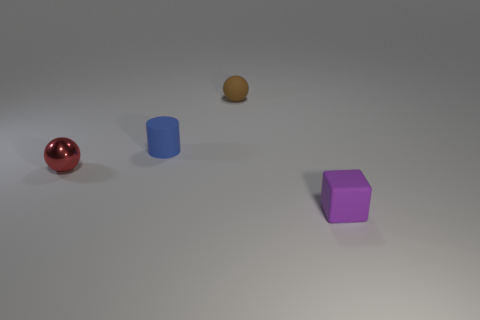Are there any tiny purple matte objects on the right side of the small purple rubber thing?
Your response must be concise. No. What number of objects are either objects that are in front of the small metal sphere or big gray blocks?
Your answer should be very brief. 1. There is a matte object that is behind the blue cylinder; what number of metal objects are left of it?
Offer a very short reply. 1. Are there fewer tiny metal spheres to the right of the tiny shiny thing than tiny brown rubber objects on the left side of the blue matte object?
Provide a short and direct response. No. What is the shape of the tiny matte thing that is to the right of the thing behind the blue thing?
Your answer should be very brief. Cube. What number of other objects are there of the same material as the small blue cylinder?
Your response must be concise. 2. Are there more small blocks than red matte things?
Provide a succinct answer. Yes. There is a sphere that is in front of the small ball behind the tiny sphere in front of the brown matte ball; what is its size?
Give a very brief answer. Small. Are there fewer purple objects in front of the brown rubber ball than cylinders?
Your answer should be compact. No. How many rubber things are the same color as the matte cube?
Provide a succinct answer. 0. 